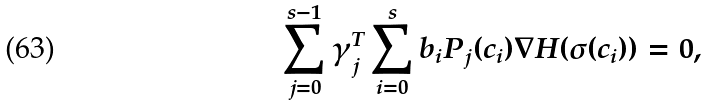Convert formula to latex. <formula><loc_0><loc_0><loc_500><loc_500>\sum _ { j = 0 } ^ { s - 1 } \gamma _ { j } ^ { T } \sum _ { i = 0 } ^ { s } b _ { i } P _ { j } ( c _ { i } ) \nabla H ( \sigma ( c _ { i } ) ) = 0 ,</formula> 